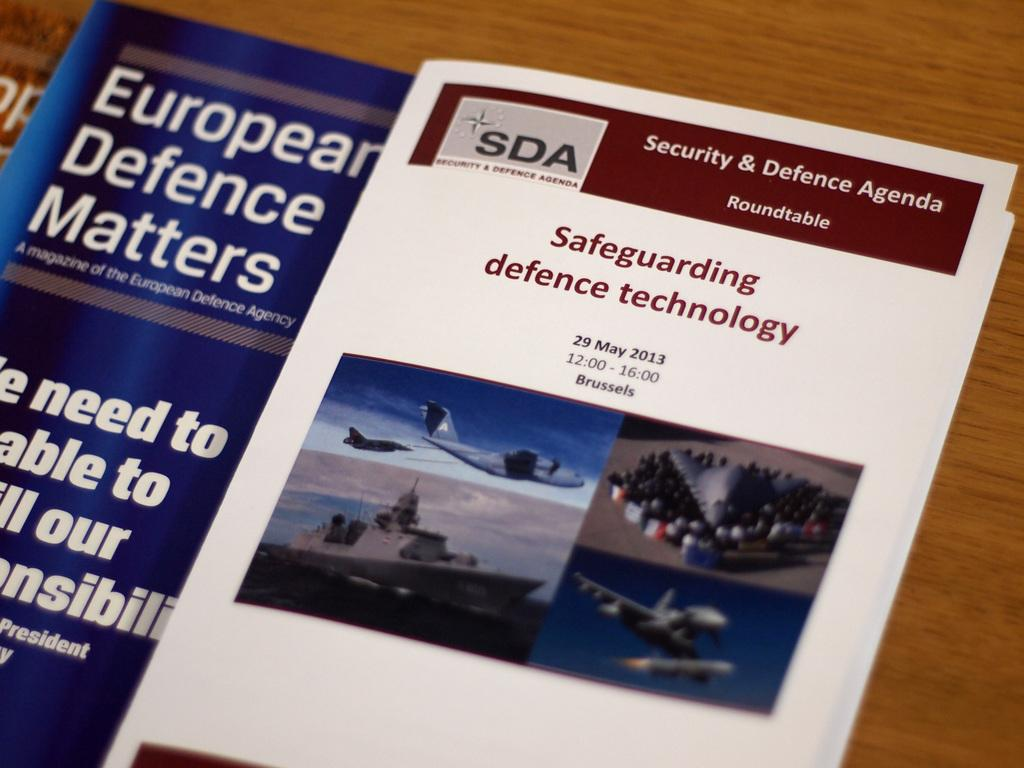<image>
Write a terse but informative summary of the picture. An open pamphlet that says Safeguarding defence technology from 2013. 